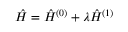<formula> <loc_0><loc_0><loc_500><loc_500>\begin{array} { r } { \hat { H } = \hat { H } ^ { ( 0 ) } + \lambda \hat { H } ^ { ( 1 ) } } \end{array}</formula> 